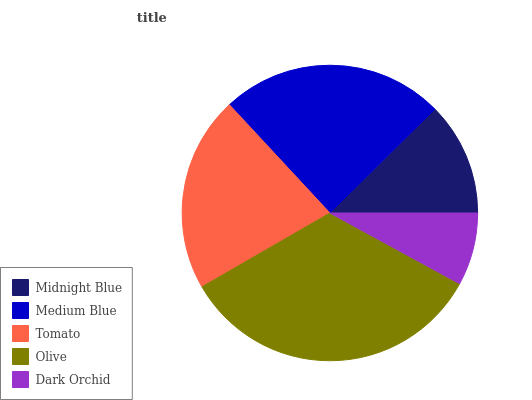Is Dark Orchid the minimum?
Answer yes or no. Yes. Is Olive the maximum?
Answer yes or no. Yes. Is Medium Blue the minimum?
Answer yes or no. No. Is Medium Blue the maximum?
Answer yes or no. No. Is Medium Blue greater than Midnight Blue?
Answer yes or no. Yes. Is Midnight Blue less than Medium Blue?
Answer yes or no. Yes. Is Midnight Blue greater than Medium Blue?
Answer yes or no. No. Is Medium Blue less than Midnight Blue?
Answer yes or no. No. Is Tomato the high median?
Answer yes or no. Yes. Is Tomato the low median?
Answer yes or no. Yes. Is Midnight Blue the high median?
Answer yes or no. No. Is Dark Orchid the low median?
Answer yes or no. No. 